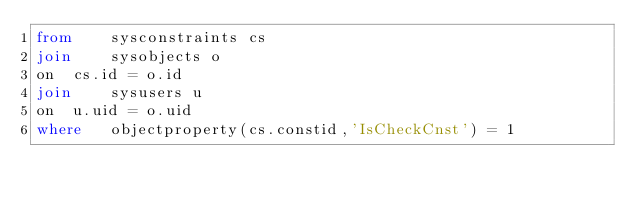Convert code to text. <code><loc_0><loc_0><loc_500><loc_500><_SQL_>from 	sysconstraints cs
join	sysobjects o
on	cs.id = o.id
join	sysusers u
on	u.uid = o.uid
where 	objectproperty(cs.constid,'IsCheckCnst') = 1</code> 